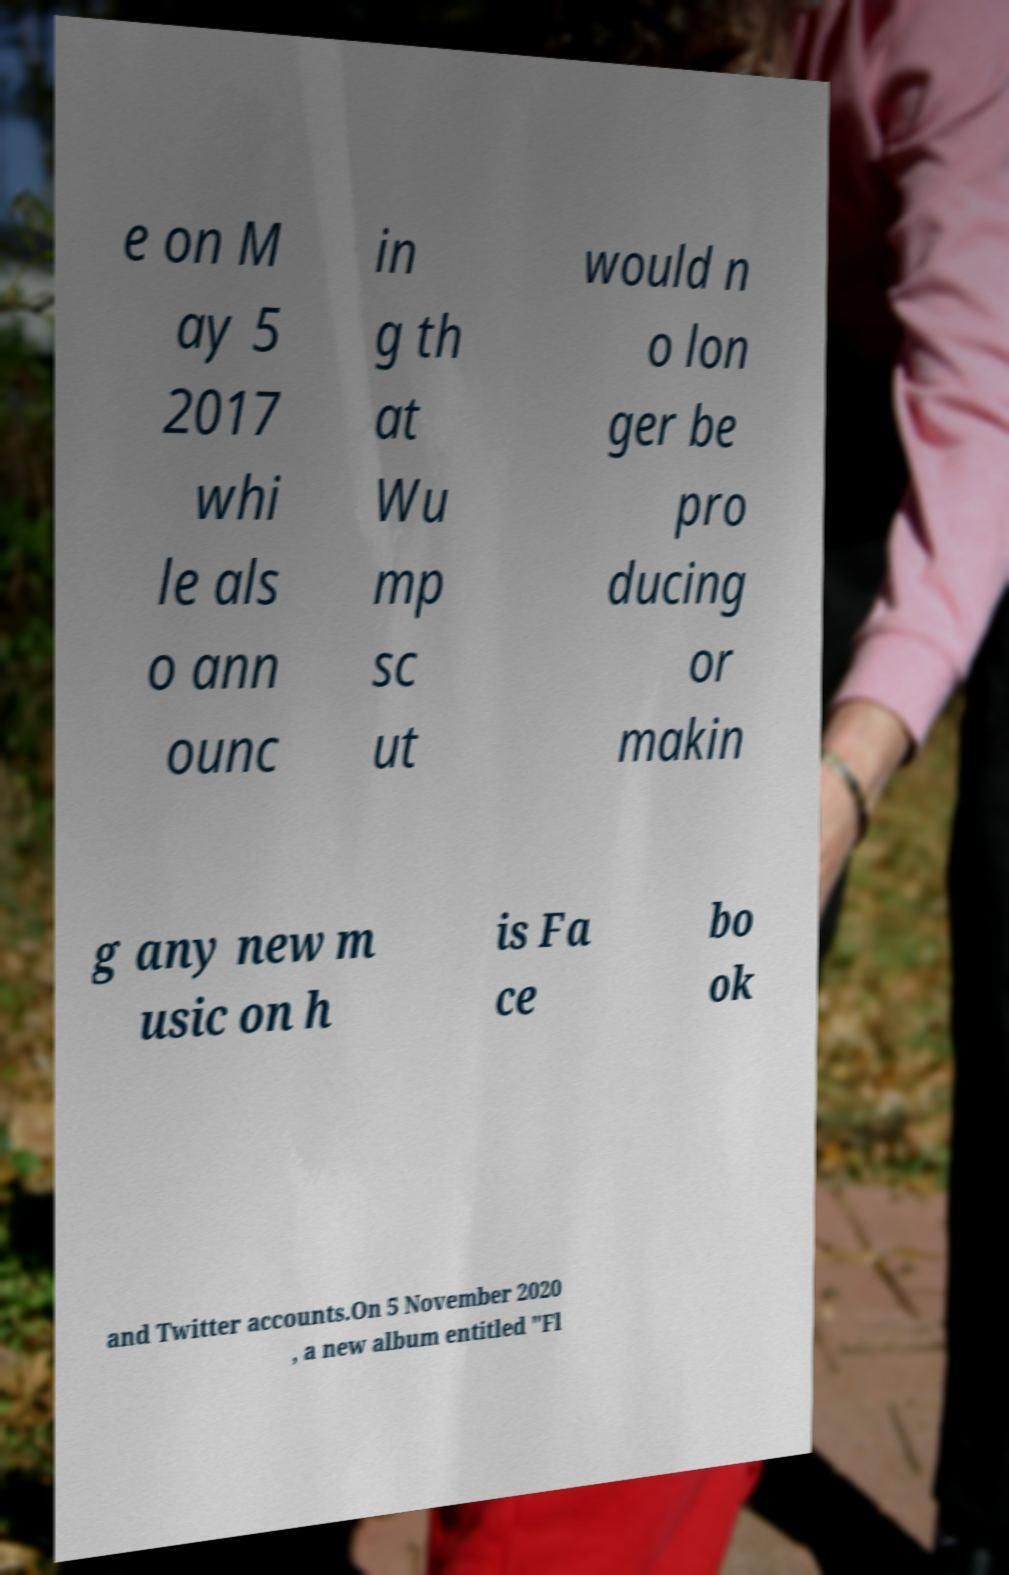Could you extract and type out the text from this image? e on M ay 5 2017 whi le als o ann ounc in g th at Wu mp sc ut would n o lon ger be pro ducing or makin g any new m usic on h is Fa ce bo ok and Twitter accounts.On 5 November 2020 , a new album entitled "Fl 